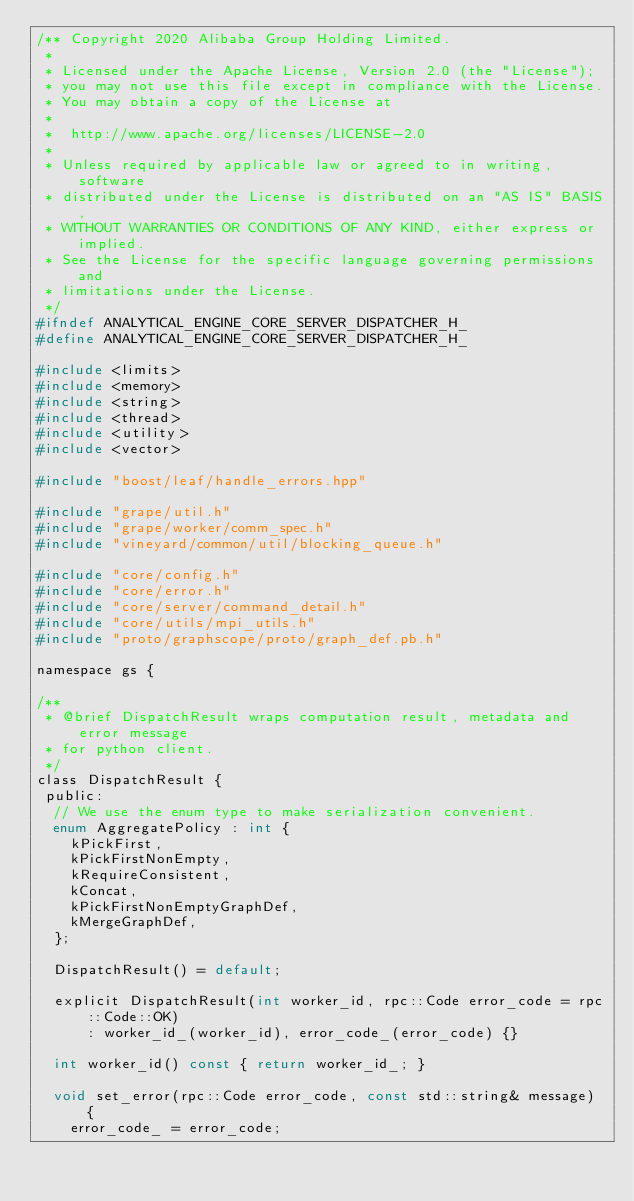<code> <loc_0><loc_0><loc_500><loc_500><_C_>/** Copyright 2020 Alibaba Group Holding Limited.
 *
 * Licensed under the Apache License, Version 2.0 (the "License");
 * you may not use this file except in compliance with the License.
 * You may obtain a copy of the License at
 *
 * 	http://www.apache.org/licenses/LICENSE-2.0
 *
 * Unless required by applicable law or agreed to in writing, software
 * distributed under the License is distributed on an "AS IS" BASIS,
 * WITHOUT WARRANTIES OR CONDITIONS OF ANY KIND, either express or implied.
 * See the License for the specific language governing permissions and
 * limitations under the License.
 */
#ifndef ANALYTICAL_ENGINE_CORE_SERVER_DISPATCHER_H_
#define ANALYTICAL_ENGINE_CORE_SERVER_DISPATCHER_H_

#include <limits>
#include <memory>
#include <string>
#include <thread>
#include <utility>
#include <vector>

#include "boost/leaf/handle_errors.hpp"

#include "grape/util.h"
#include "grape/worker/comm_spec.h"
#include "vineyard/common/util/blocking_queue.h"

#include "core/config.h"
#include "core/error.h"
#include "core/server/command_detail.h"
#include "core/utils/mpi_utils.h"
#include "proto/graphscope/proto/graph_def.pb.h"

namespace gs {

/**
 * @brief DispatchResult wraps computation result, metadata and error message
 * for python client.
 */
class DispatchResult {
 public:
  // We use the enum type to make serialization convenient.
  enum AggregatePolicy : int {
    kPickFirst,
    kPickFirstNonEmpty,
    kRequireConsistent,
    kConcat,
    kPickFirstNonEmptyGraphDef,
    kMergeGraphDef,
  };

  DispatchResult() = default;

  explicit DispatchResult(int worker_id, rpc::Code error_code = rpc::Code::OK)
      : worker_id_(worker_id), error_code_(error_code) {}

  int worker_id() const { return worker_id_; }

  void set_error(rpc::Code error_code, const std::string& message) {
    error_code_ = error_code;</code> 